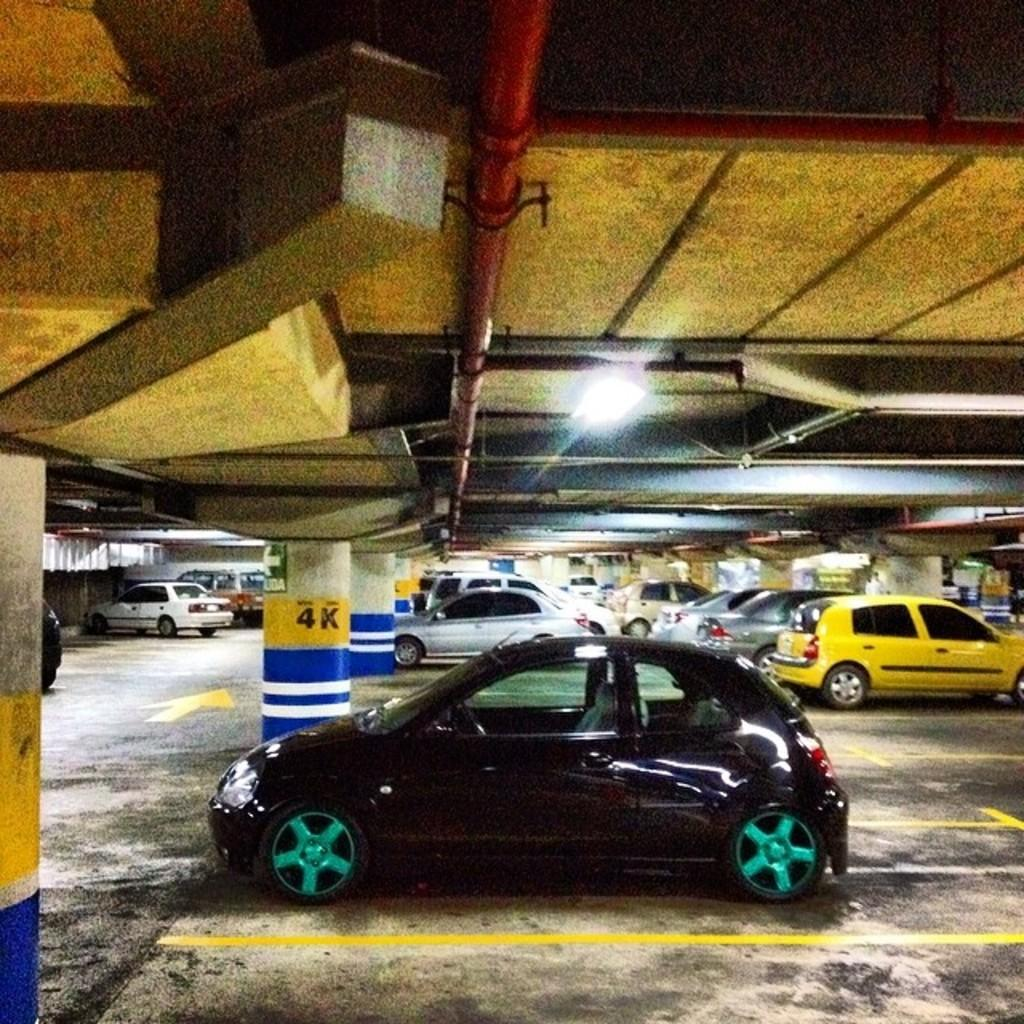<image>
Share a concise interpretation of the image provided. a 4k sign with a car next to it 